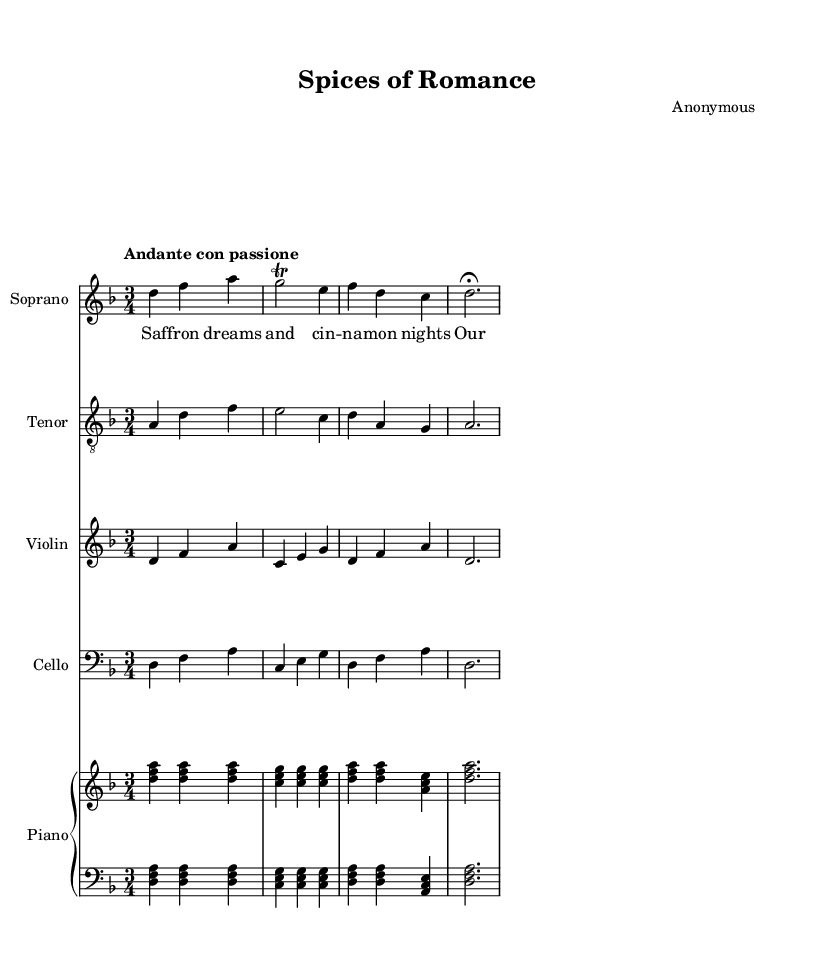What is the key signature of this music? The key signature is D minor, which has one flat (Bb) indicated on the staff at the beginning of the sheet music.
Answer: D minor What is the time signature of this music? The time signature is 3/4, which means there are three beats in each measure and the quarter note gets one beat, as shown at the beginning of the sheet music.
Answer: 3/4 What is the tempo marking of this piece? The tempo marking is "Andante con passione," which suggests a moderately slow tempo with passion, as noted at the beginning of the music.
Answer: Andante con passione How many measures are in the soprano part? There are four measures in the soprano part, indicated by the dividing lines on the staff where the notes are grouped.
Answer: 4 What is the highest note in the soprano part? The highest note in the soprano part is A, which can be found in measure 1, as this note appears above all other notes in that part.
Answer: A How does the cello part compare to the violin part? The cello part is identical to the violin part, as both parts are shown to play the same pitches and rhythms throughout the piece, indicating harmony or unison.
Answer: Identical What is the main theme of the lyrics in this opera? The main theme of the lyrics revolves around love and romance in exotic settings, as illustrated by the imagery in the text provided.
Answer: Love and romance 